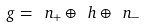Convert formula to latex. <formula><loc_0><loc_0><loc_500><loc_500>\ g = \ n _ { + } \oplus \ h \oplus \ n _ { - }</formula> 